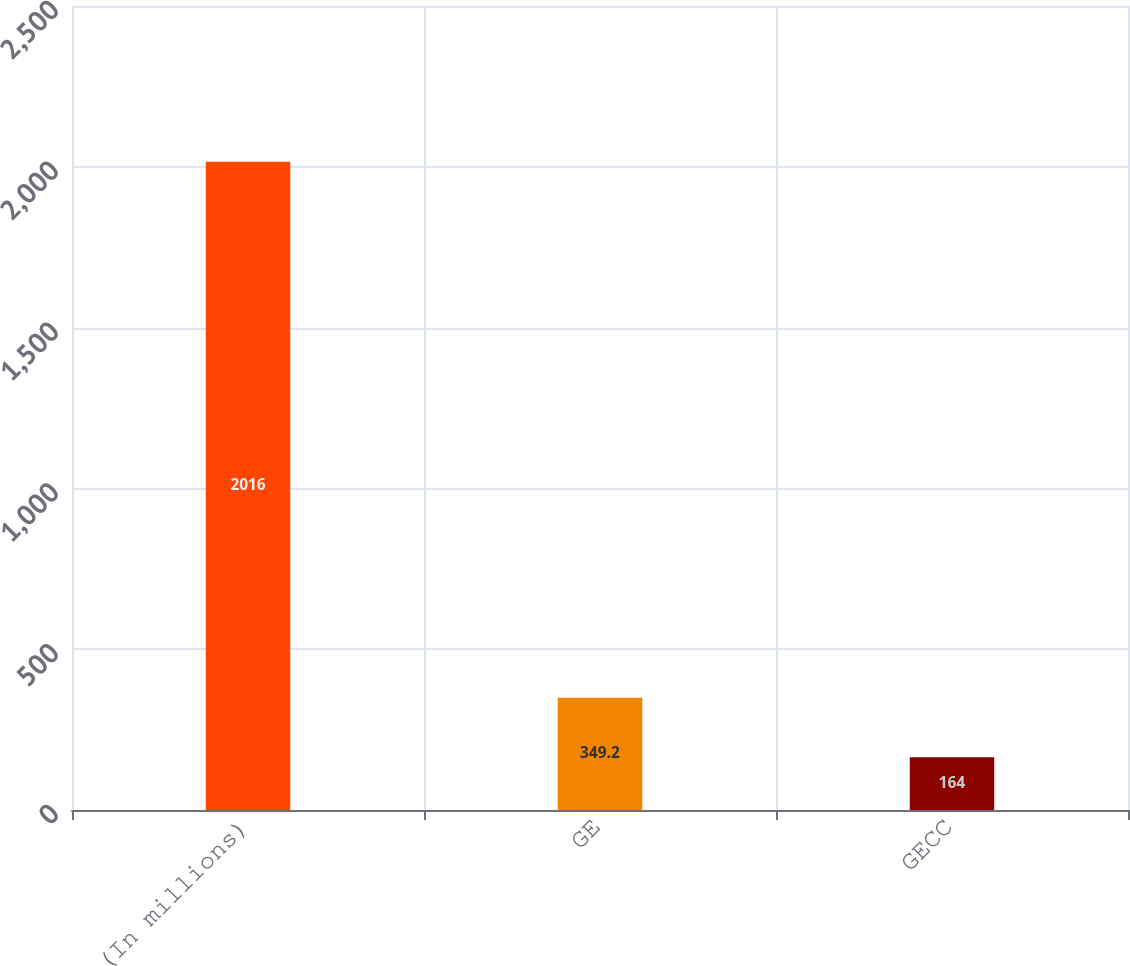Convert chart. <chart><loc_0><loc_0><loc_500><loc_500><bar_chart><fcel>(In millions)<fcel>GE<fcel>GECC<nl><fcel>2016<fcel>349.2<fcel>164<nl></chart> 